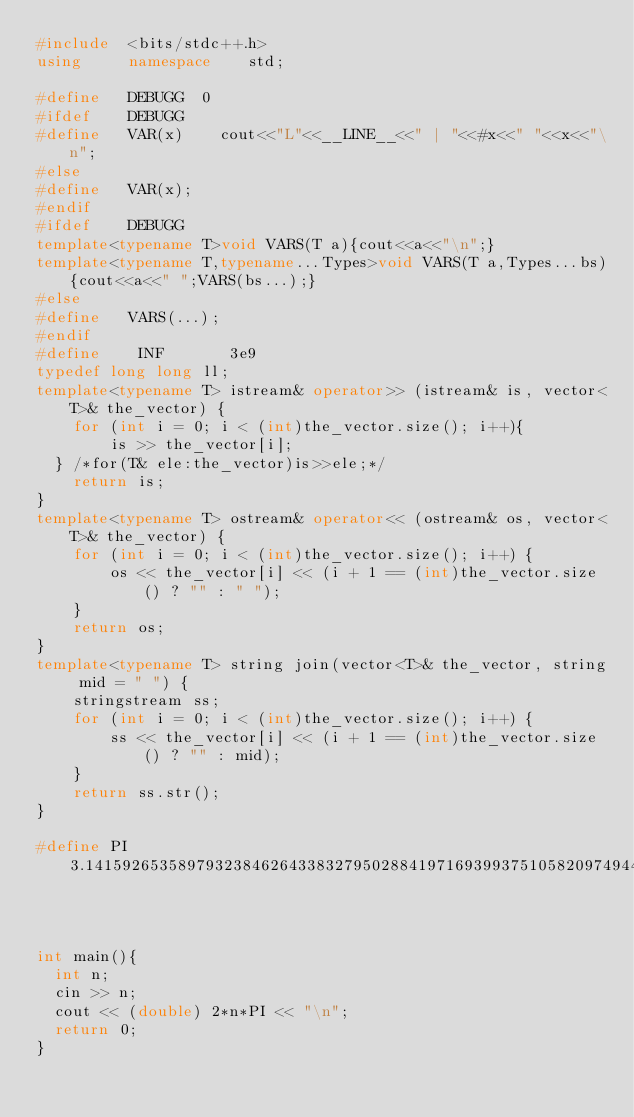Convert code to text. <code><loc_0><loc_0><loc_500><loc_500><_C++_>#include  <bits/stdc++.h>
using     namespace    std;

#define   DEBUGG	0
#ifdef    DEBUGG
#define   VAR(x)    cout<<"L"<<__LINE__<<" | "<<#x<<" "<<x<<"\n";
#else
#define   VAR(x);
#endif
#ifdef    DEBUGG
template<typename T>void VARS(T a){cout<<a<<"\n";}
template<typename T,typename...Types>void VARS(T a,Types...bs){cout<<a<<" ";VARS(bs...);}
#else
#define   VARS(...);
#endif
#define    INF       3e9
typedef long long ll;
template<typename T> istream& operator>> (istream& is, vector<T>& the_vector) {
    for (int i = 0; i < (int)the_vector.size(); i++){
        is >> the_vector[i];
	} /*for(T& ele:the_vector)is>>ele;*/
    return is;
}
template<typename T> ostream& operator<< (ostream& os, vector<T>& the_vector) {
    for (int i = 0; i < (int)the_vector.size(); i++) {
        os << the_vector[i] << (i + 1 == (int)the_vector.size() ? "" : " ");
    }
    return os;
}
template<typename T> string join(vector<T>& the_vector, string mid = " ") {
    stringstream ss;
    for (int i = 0; i < (int)the_vector.size(); i++) {
        ss << the_vector[i] << (i + 1 == (int)the_vector.size() ? "" : mid);
    }
    return ss.str();
}

#define PI 3.1415926535897932384626433832795028841971693993751058209749445923078164



int main(){
	int n;
	cin >> n;
	cout << (double) 2*n*PI << "\n";
	return 0;
}</code> 